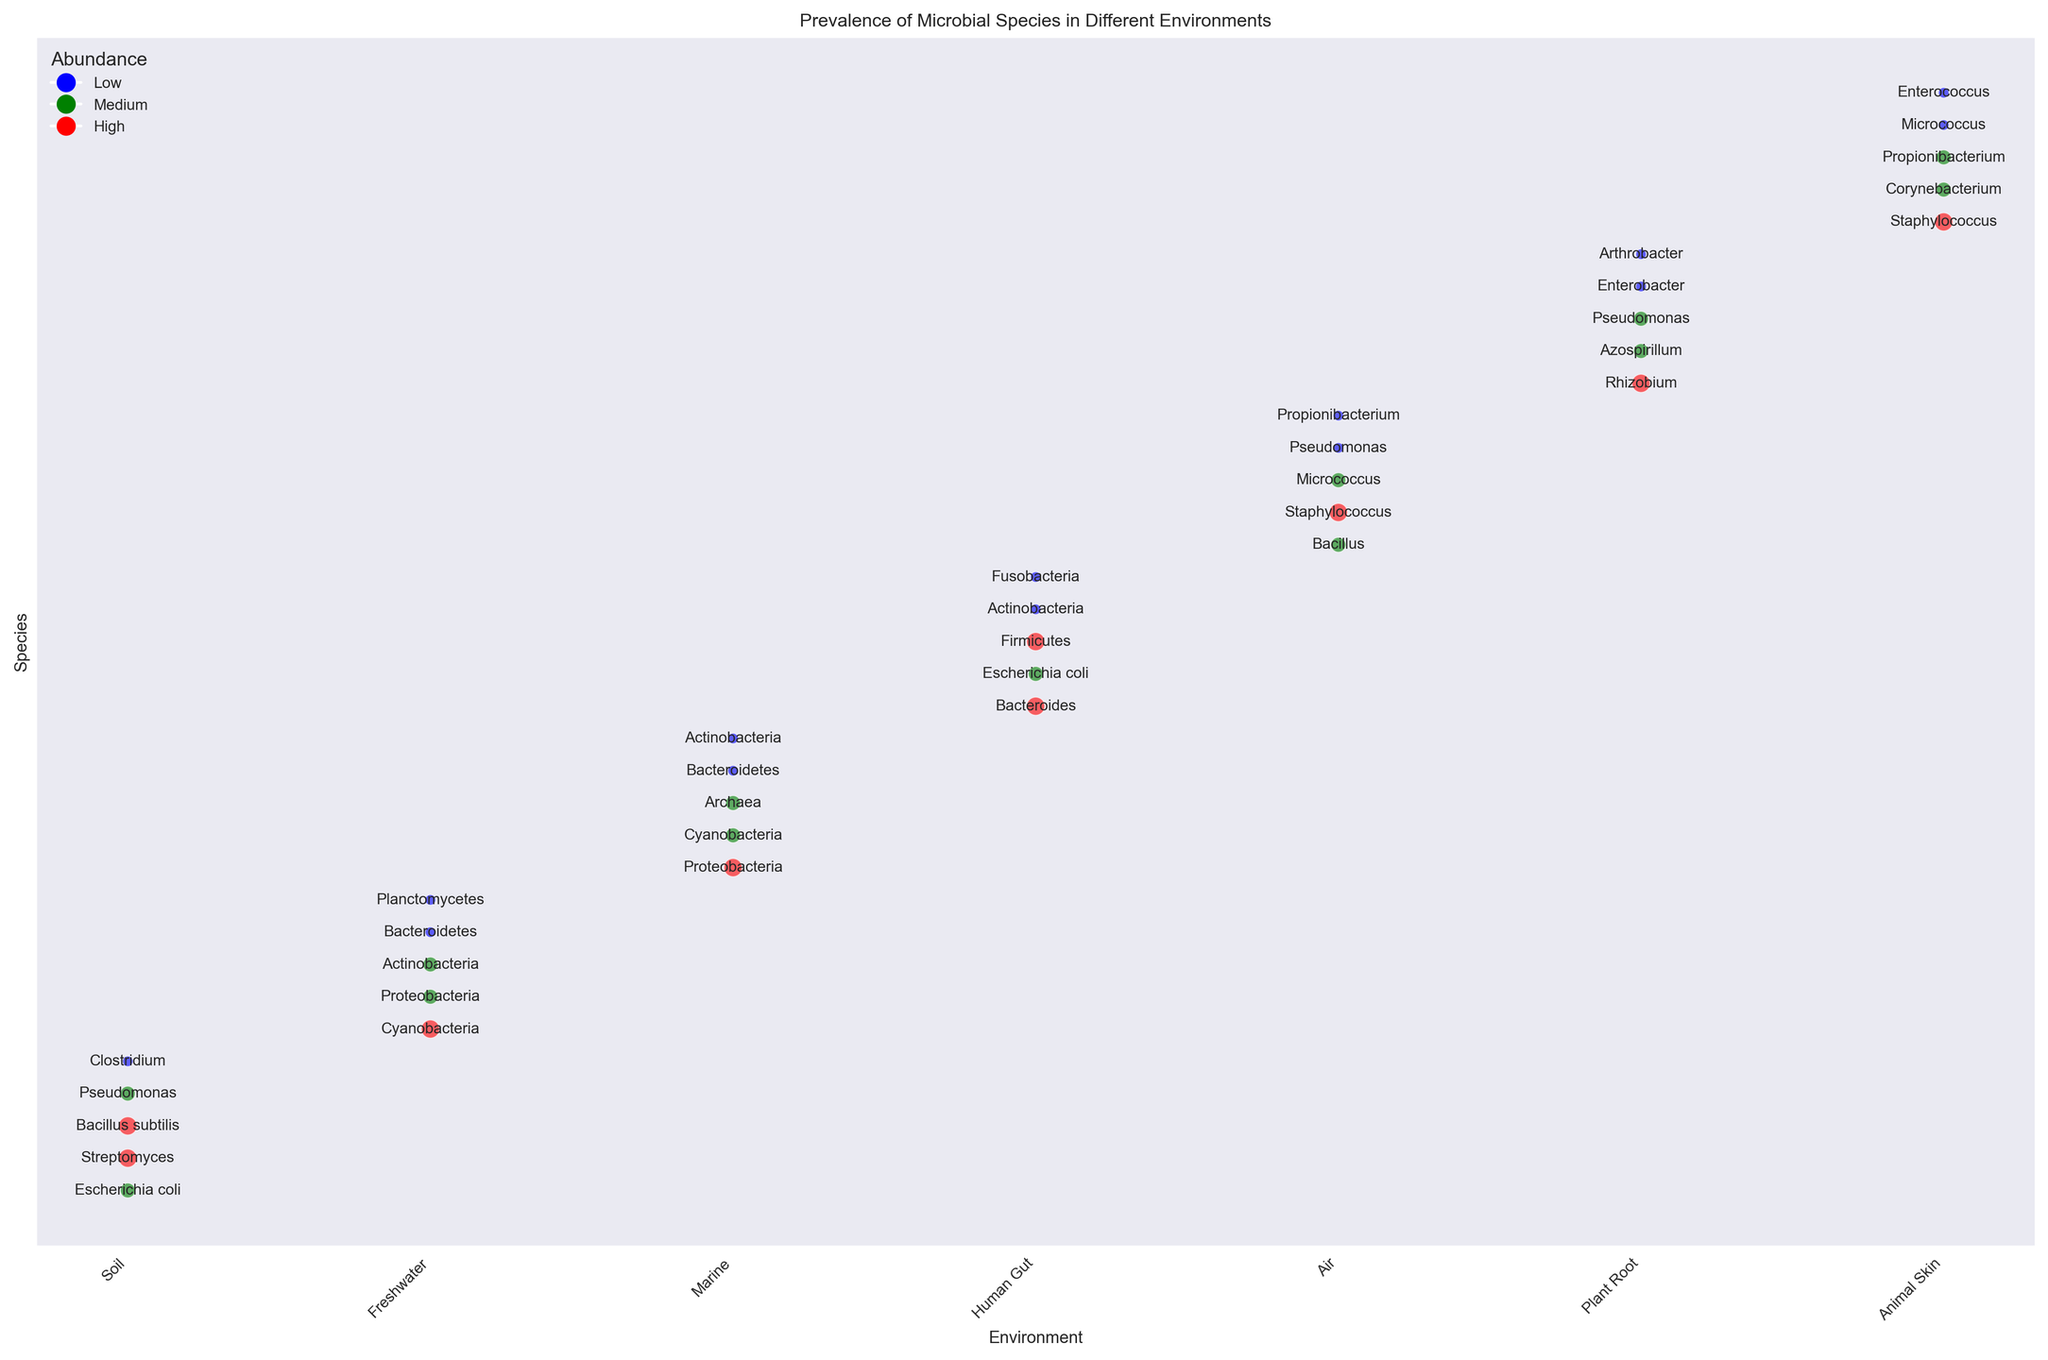Which environment has the highest prevalence of Streptomyces? Streptomyces appears only in the Soil environment with a high abundance, which is indicated by a large red bubble.
Answer: Soil How many species have high abundance in the Soil environment? In the Soil environment, three species (Streptomyces, Bacillus subtilis, and Streptomyces) have a high abundance, indicated by red bubbles.
Answer: 3 Which environments contain Actinobacteria, and what is their abundance in each? Freshwater, Marine, and Human Gut environments contain Actinobacteria. Freshwater has a medium (green) abundance, while Marine and Human Gut both have low (blue) abundance.
Answer: Freshwater (Medium), Marine (Low), Human Gut (Low) What is the total number of microbial species identified in the Air environment? In the Air environment, five species (Bacillus, Staphylococcus, Micrococcus, Pseudomonas, Propionibacterium) are identified.
Answer: 5 Compare the abundance levels of Proteobacteria in Freshwater and Marine environments. Which is higher? In the Freshwater environment, Proteobacteria has a medium (green) abundance, whereas in the Marine environment, it has a high (red) abundance.
Answer: Marine Which species has medium abundance in both the Human Gut and Soil environments? Escherichia coli has medium (green) abundance in both the Human Gut and Soil environments.
Answer: Escherichia coli How many species in the Marine environment have a low abundance? In the Marine environment, there are two species (Bacteroidetes and Actinobacteria) with low (blue) abundance.
Answer: 2 What is the prevalence of Pseudomonas in Soil compared to Plant Root environments? Pseudomonas has a medium (green) abundance in both the Soil and Plant Root environments.
Answer: Equal Which environment has more species with high abundance, Soil or Freshwater? The Soil environment has three species with high (red) abundance (Streptomyces, Bacillus subtilis, Streptomyces), whereas Freshwater has only one species with high (red) abundance (Cyanobacteria).
Answer: Soil 